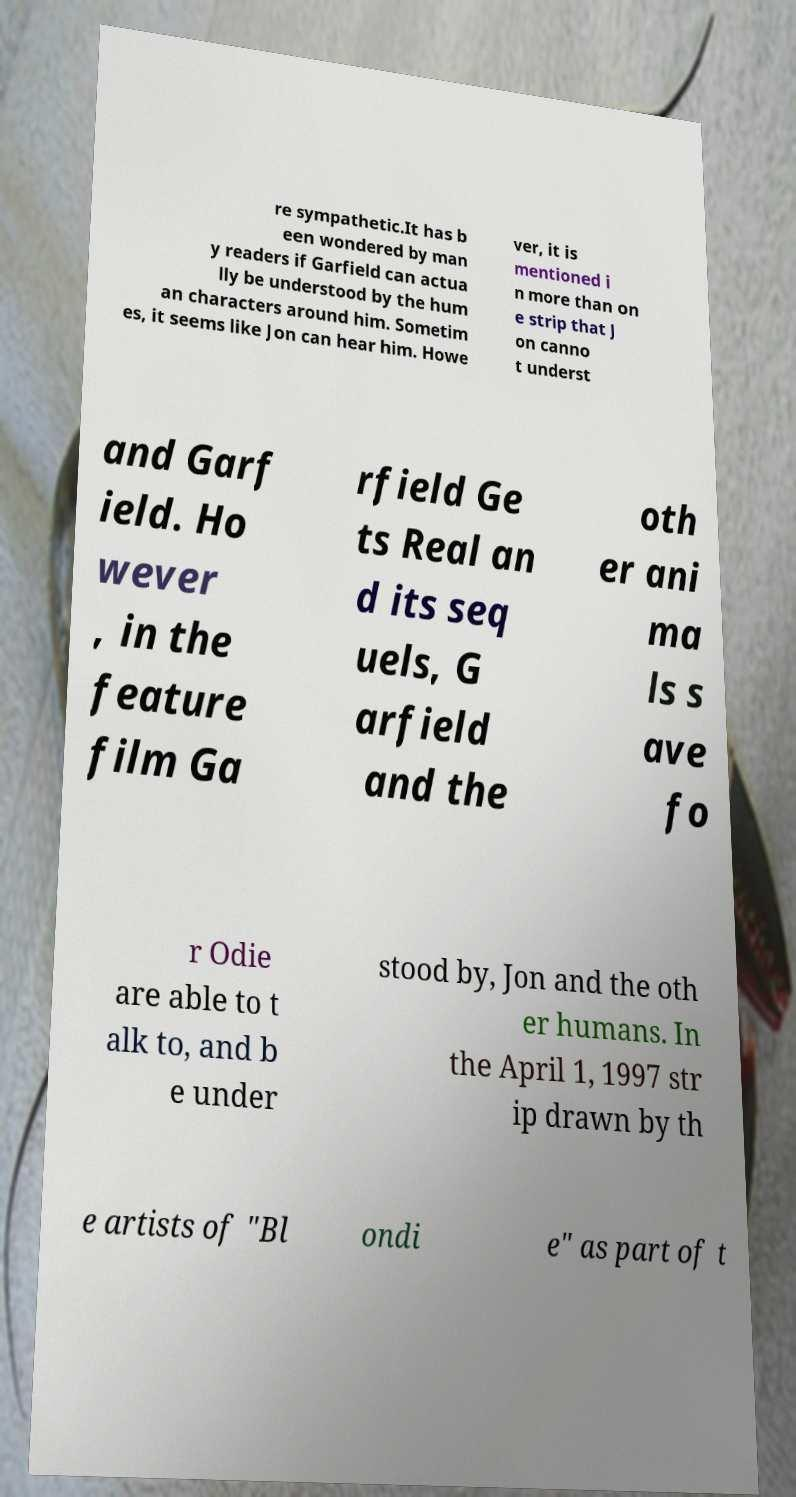What messages or text are displayed in this image? I need them in a readable, typed format. re sympathetic.It has b een wondered by man y readers if Garfield can actua lly be understood by the hum an characters around him. Sometim es, it seems like Jon can hear him. Howe ver, it is mentioned i n more than on e strip that J on canno t underst and Garf ield. Ho wever , in the feature film Ga rfield Ge ts Real an d its seq uels, G arfield and the oth er ani ma ls s ave fo r Odie are able to t alk to, and b e under stood by, Jon and the oth er humans. In the April 1, 1997 str ip drawn by th e artists of "Bl ondi e" as part of t 